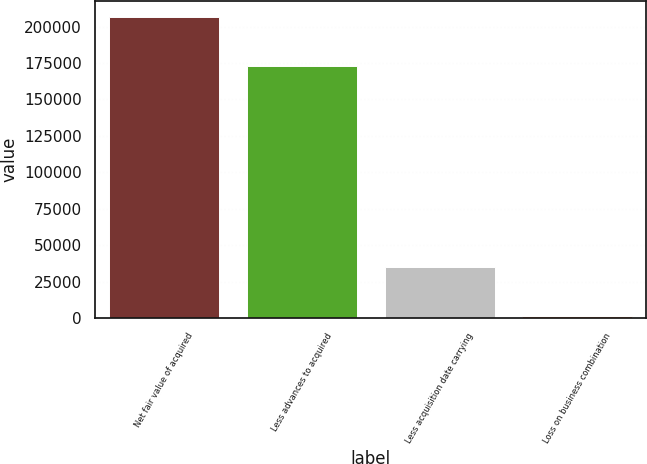<chart> <loc_0><loc_0><loc_500><loc_500><bar_chart><fcel>Net fair value of acquired<fcel>Less advances to acquired<fcel>Less acquisition date carrying<fcel>Loss on business combination<nl><fcel>206852<fcel>173006<fcel>34908<fcel>1062<nl></chart> 